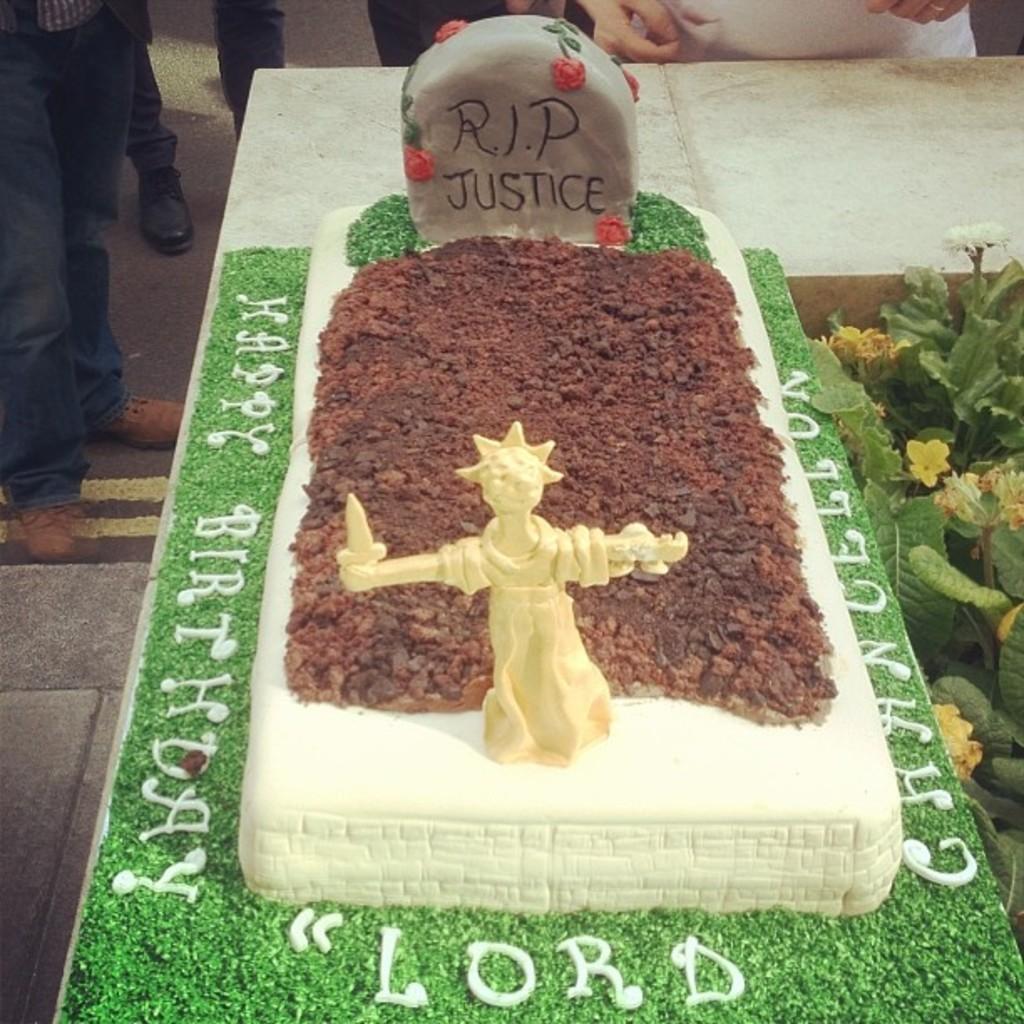Could you give a brief overview of what you see in this image? In this picture we can see a grave. There is some soil and an idol on this grave. We can see some flowers and plants on the left side. Few people are standing in the background. 